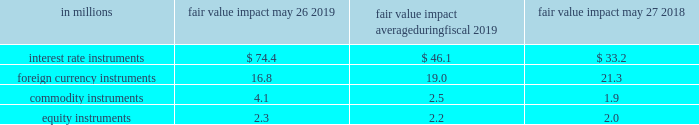The table below presents the estimated maximum potential var arising from a one-day loss in fair value for our interest rate , foreign currency , commodity , and equity market-risk-sensitive instruments outstanding as of may 26 , 2019 and may 27 , 2018 , and the average fair value impact during the year ended may 26 , 2019. .

What is the change in fair value of equity instruments from 2018 to 2019? 
Computations: (2.3 - 2.0)
Answer: 0.3. 